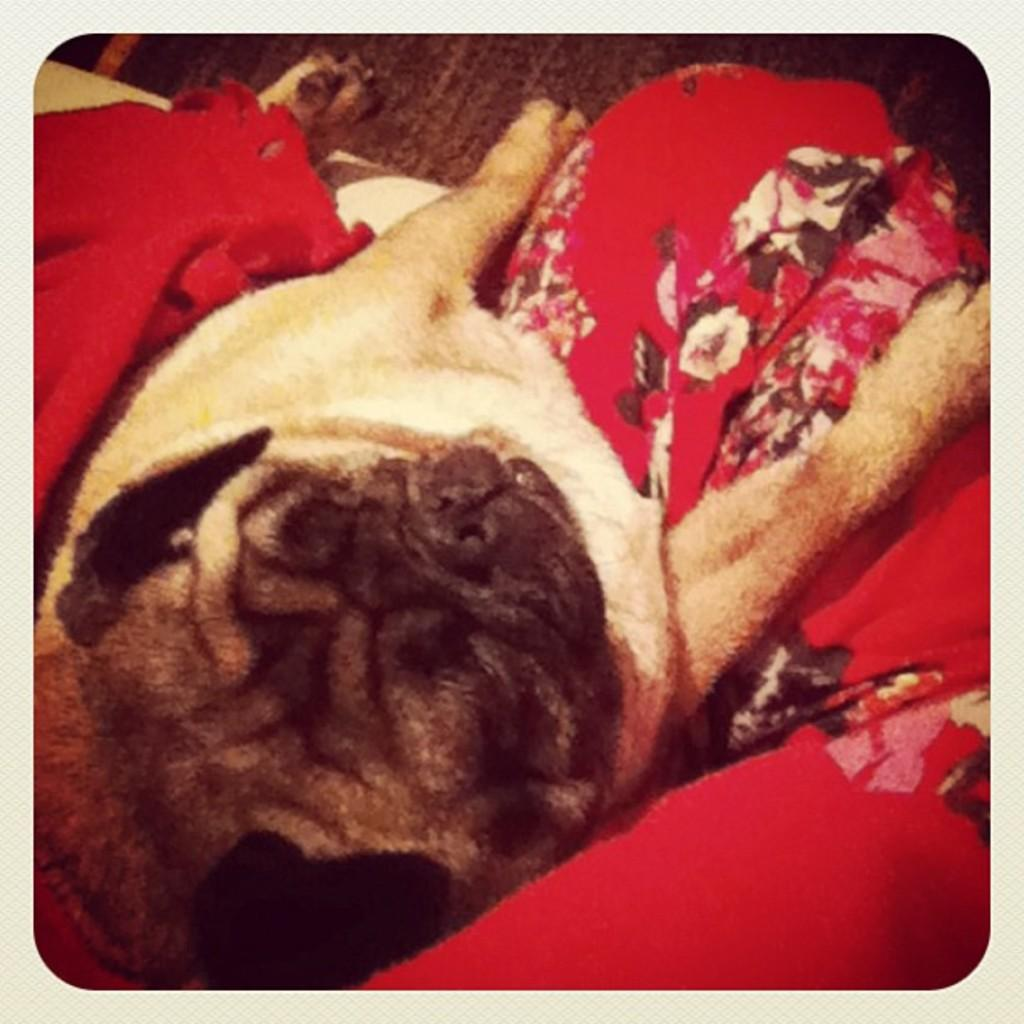What type of animal is in the image? There is a dog in the image. What colors can be seen on the dog? The dog is in cream and black colors. Is the dog wearing anything in the image? Yes, the dog is wearing a red cloth. What can be seen in the background of the image? There is a floor visible in the background of the image. What type of boat is the dog cooking in the image? There is no boat or cooking activity present in the image; it features a dog wearing a red cloth and standing on a floor. 